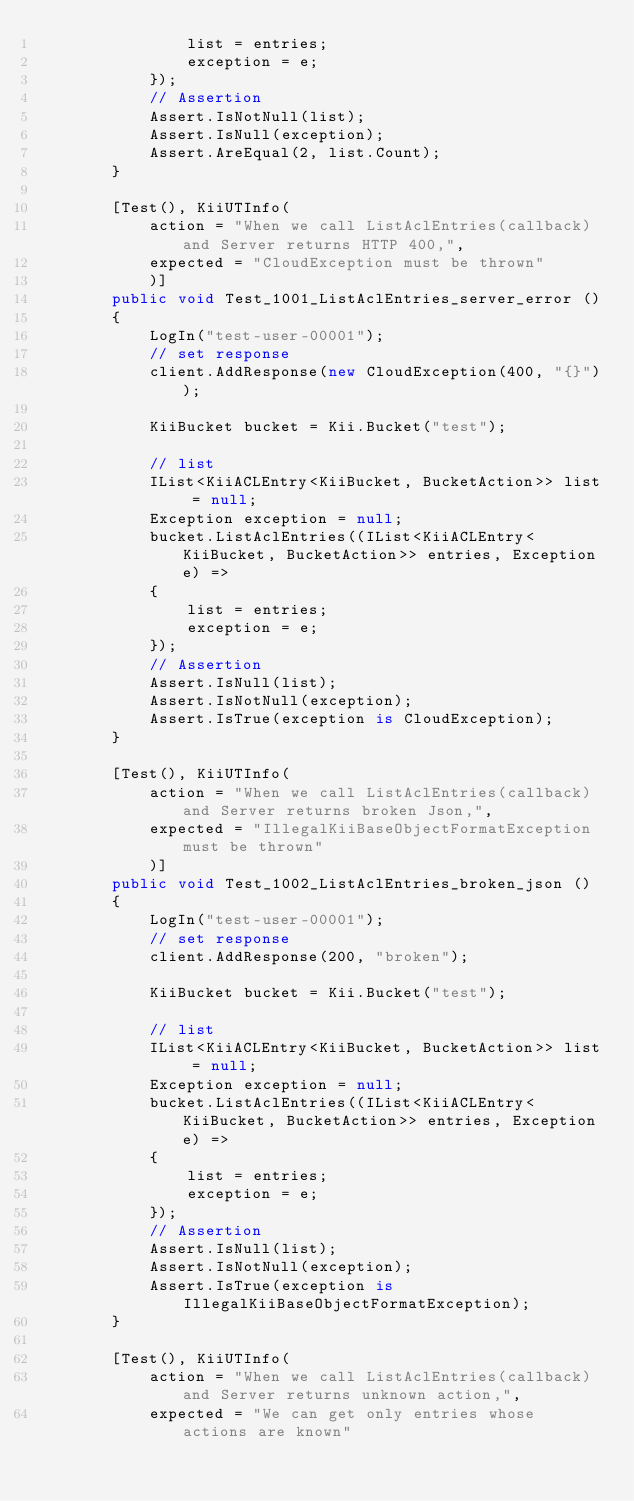<code> <loc_0><loc_0><loc_500><loc_500><_C#_>                list = entries;
                exception = e;
            });
            // Assertion
            Assert.IsNotNull(list);
            Assert.IsNull(exception);
            Assert.AreEqual(2, list.Count);
        }
        
        [Test(), KiiUTInfo(
            action = "When we call ListAclEntries(callback) and Server returns HTTP 400,",
            expected = "CloudException must be thrown"
            )]
        public void Test_1001_ListAclEntries_server_error ()
        {
            LogIn("test-user-00001");
            // set response
            client.AddResponse(new CloudException(400, "{}"));
            
            KiiBucket bucket = Kii.Bucket("test");
            
            // list
            IList<KiiACLEntry<KiiBucket, BucketAction>> list = null;
            Exception exception = null;
            bucket.ListAclEntries((IList<KiiACLEntry<KiiBucket, BucketAction>> entries, Exception e) =>
            {
                list = entries;
                exception = e;
            });
            // Assertion
            Assert.IsNull(list);
            Assert.IsNotNull(exception);
            Assert.IsTrue(exception is CloudException);
        }
        
        [Test(), KiiUTInfo(
            action = "When we call ListAclEntries(callback) and Server returns broken Json,",
            expected = "IllegalKiiBaseObjectFormatException must be thrown"
            )]
        public void Test_1002_ListAclEntries_broken_json ()
        {
            LogIn("test-user-00001");
            // set response
            client.AddResponse(200, "broken");
            
            KiiBucket bucket = Kii.Bucket("test");
            
            // list
            IList<KiiACLEntry<KiiBucket, BucketAction>> list = null;
            Exception exception = null;
            bucket.ListAclEntries((IList<KiiACLEntry<KiiBucket, BucketAction>> entries, Exception e) =>
            {
                list = entries;
                exception = e;
            });
            // Assertion
            Assert.IsNull(list);
            Assert.IsNotNull(exception);
            Assert.IsTrue(exception is IllegalKiiBaseObjectFormatException);
        }
        
        [Test(), KiiUTInfo(
            action = "When we call ListAclEntries(callback) and Server returns unknown action,",
            expected = "We can get only entries whose actions are known"</code> 